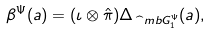Convert formula to latex. <formula><loc_0><loc_0><loc_500><loc_500>\beta ^ { \Psi } ( a ) = ( \iota \otimes \hat { \pi } ) \Delta _ { \widehat { \ } m b G ^ { \Psi } _ { 1 } } ( a ) ,</formula> 